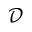Convert formula to latex. <formula><loc_0><loc_0><loc_500><loc_500>\mathcal { D }</formula> 